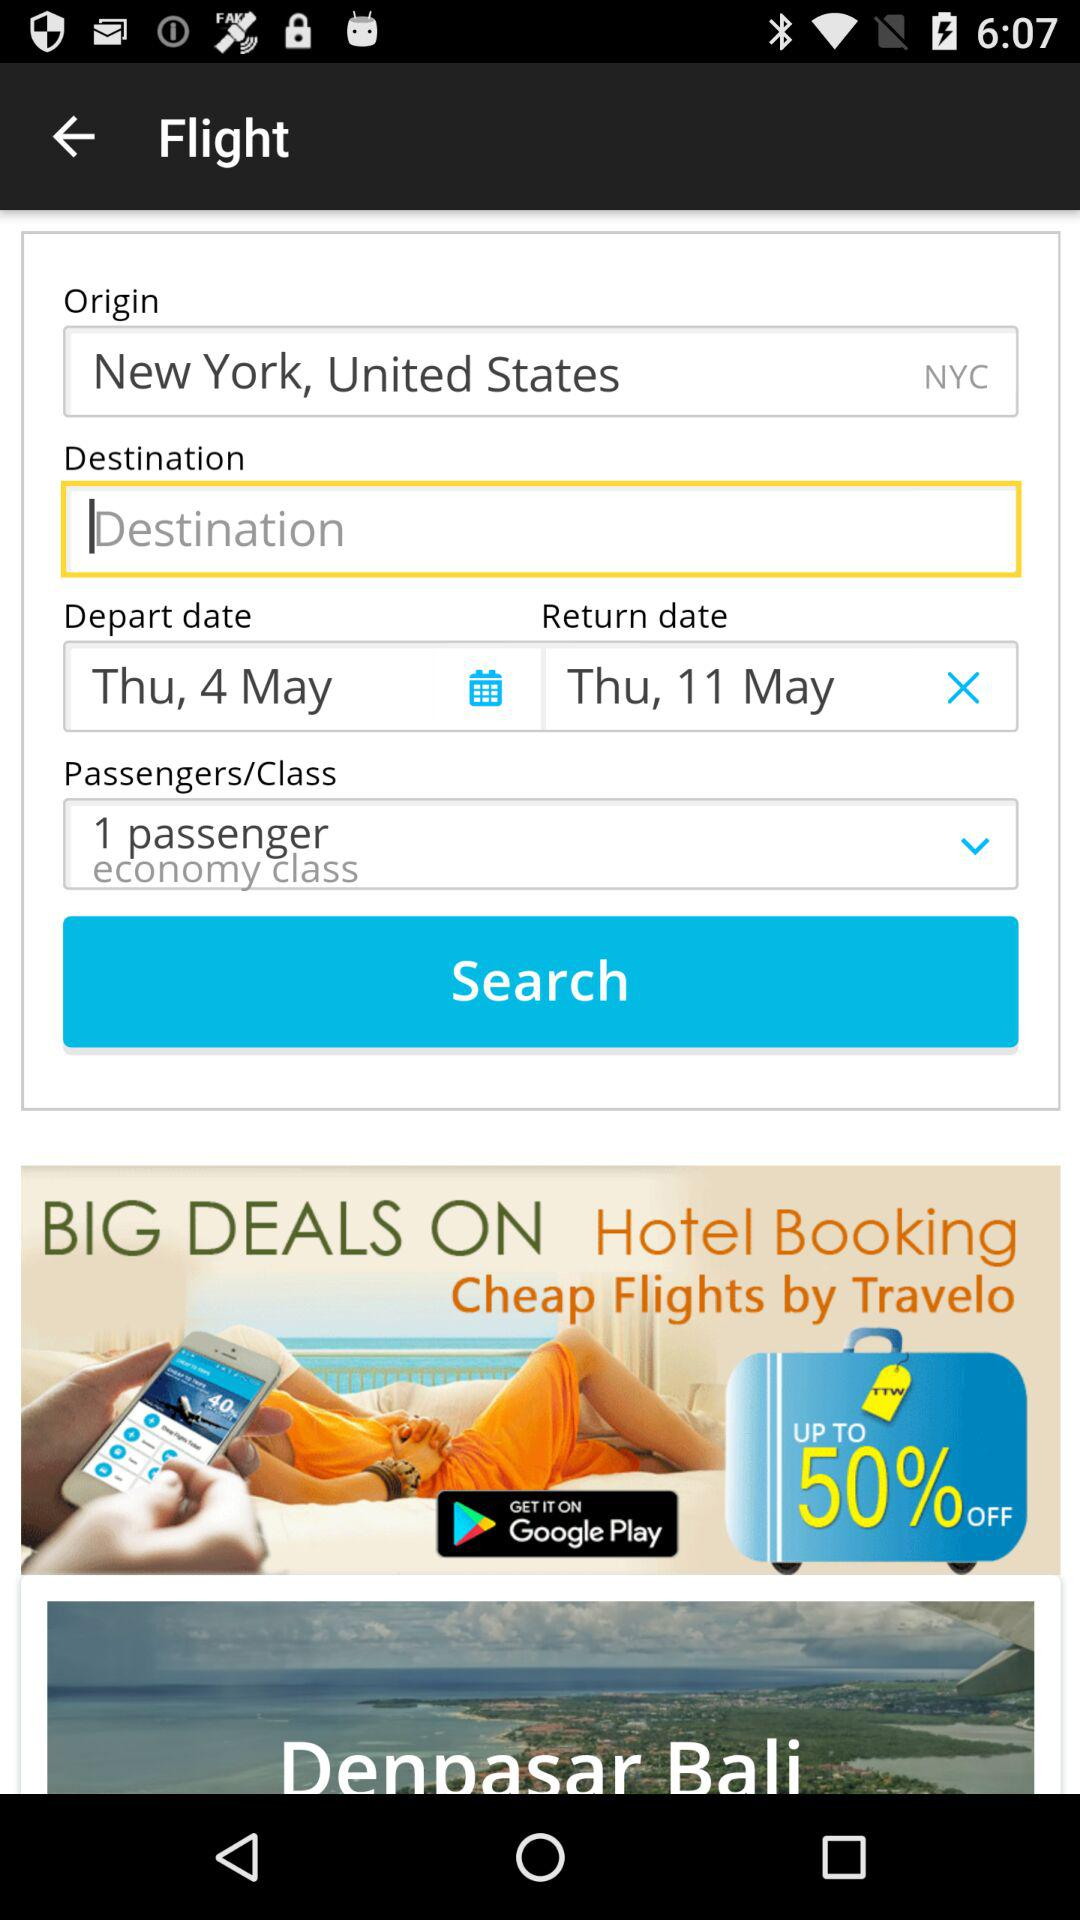Which class is selected? The selected class is economy. 